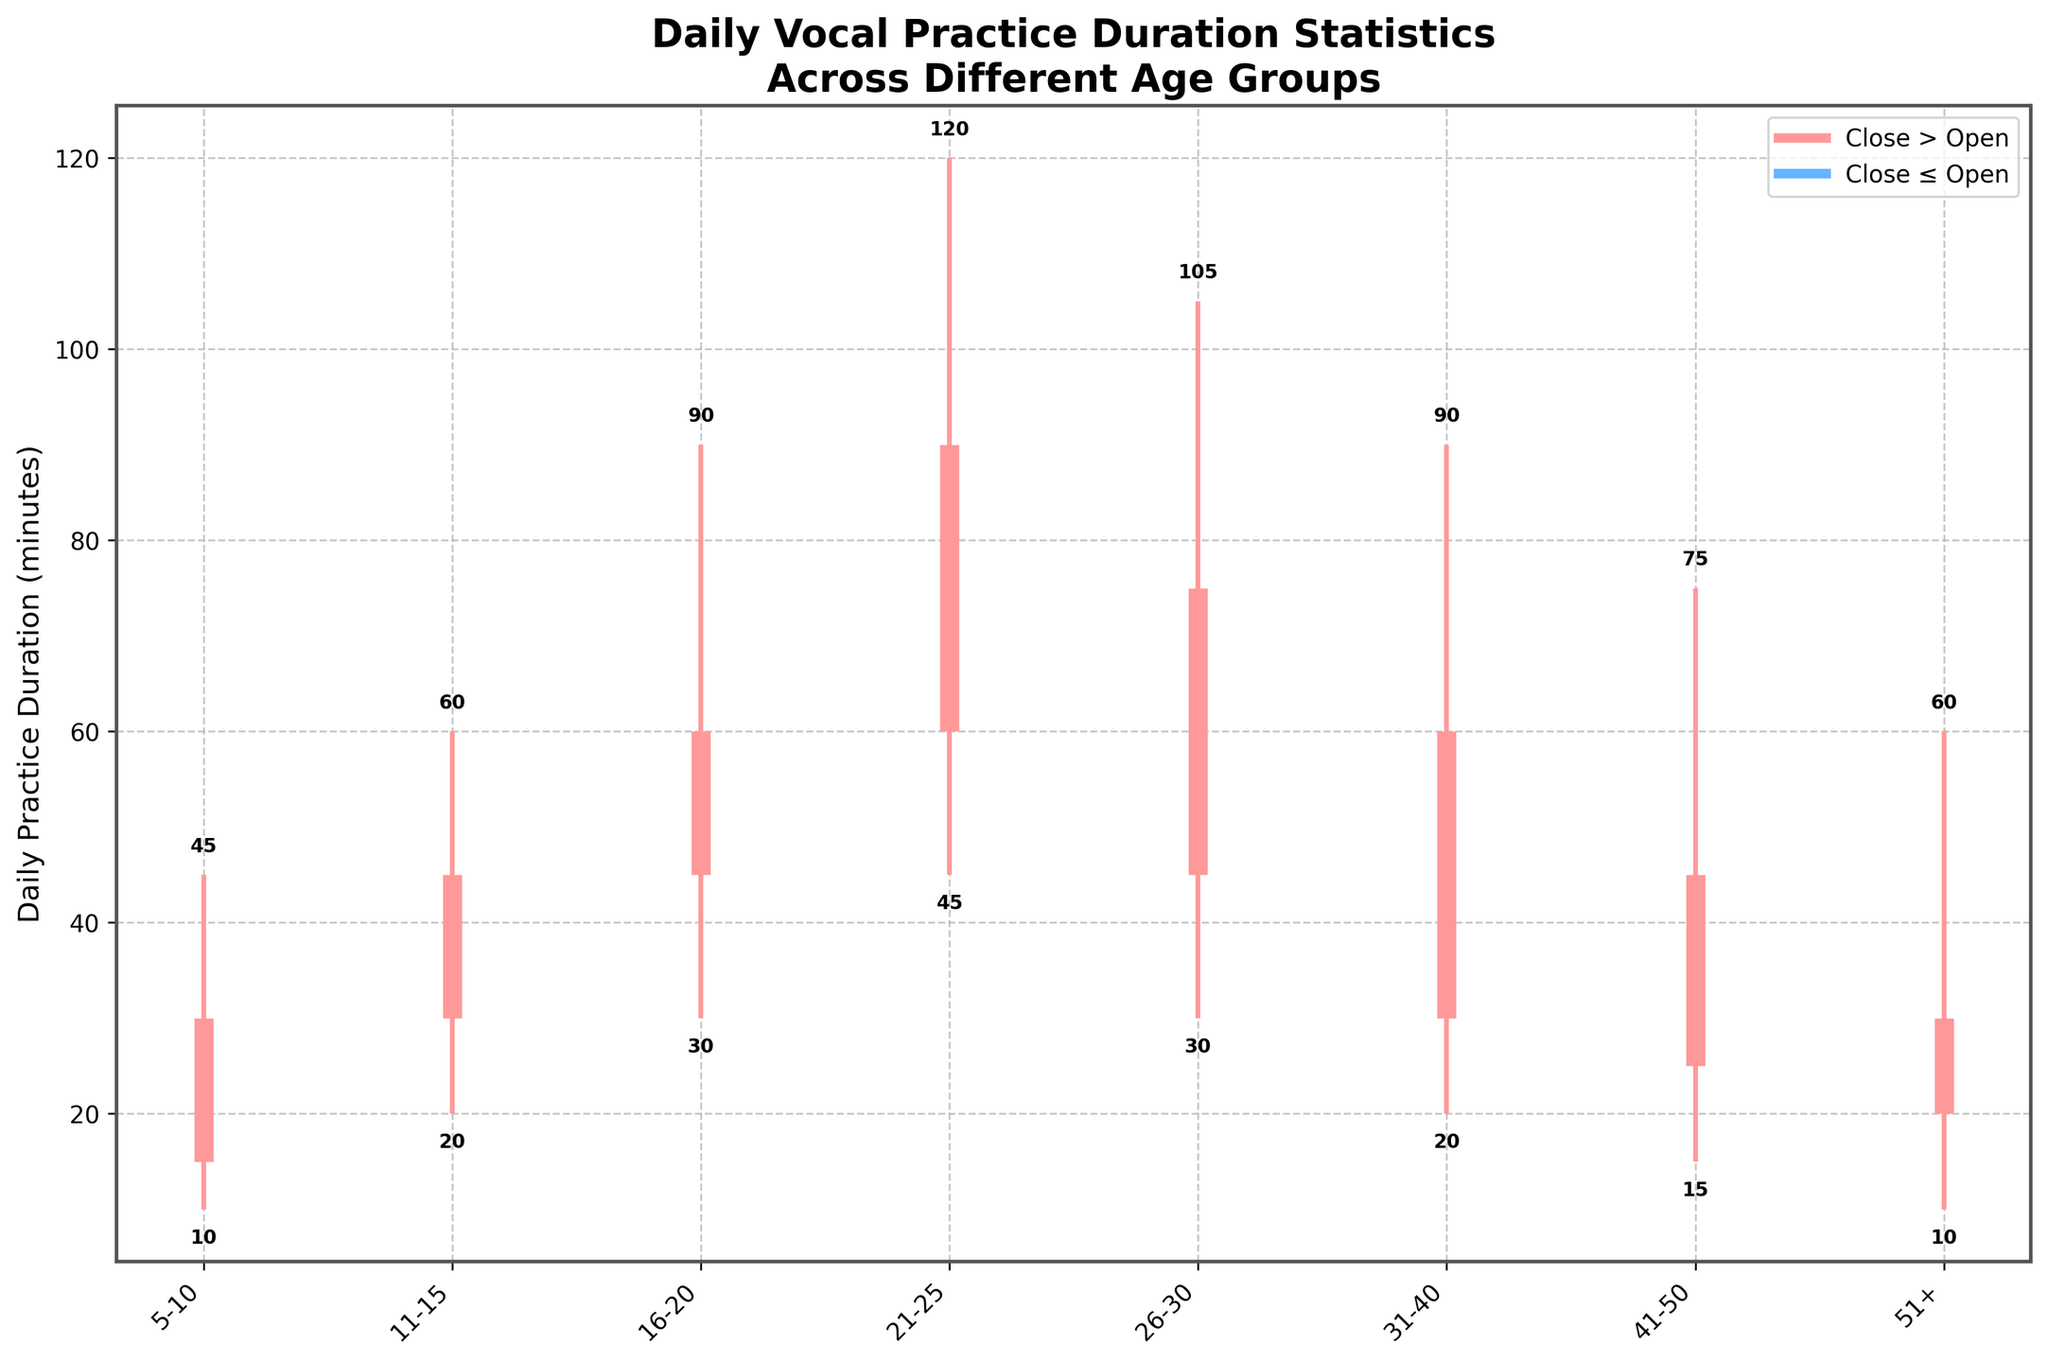What is the high value for the 21-25 age group? The high value for the 21-25 age group can be found by locating the highest point of the line representing that age group.
Answer: 120 Which age group has the smallest low value? The age group with the smallest low value can be identified by observing the lowest point reached by the lines.
Answer: 51+ What is the difference between the open and close values for the 16-20 age group? Subtract the open value from the close value for the 16-20 age group (60 - 45 = 15).
Answer: 15 Which age group had the highest variation in practice durations (difference between high and low values)? The variation is calculated by subtracting the low value from the high value for each age group. The largest difference indicates the highest variation.
Answer: 21-25 How many age groups have a close value greater than their open value? Count the number of age groups where the close value is higher than the open value. This can be visually identified by the thicker horizontal lines being above their starting points (open).
Answer: 6 What is the average of the close values for the age groups between 31-40 and 51+? Add the close values for the age groups 31-40 and 51+ and then divide by the number of age groups to find the average ((60 + 45 + 30) / 3).
Answer: 45 What is the range of the close values in the dataset? The range is calculated by subtracting the smallest close value from the largest close value (90 - 30 = 60).
Answer: 60 Which age group has the smallest difference between their high and low values? Calculate the difference between high and low values for each age group and identify the smallest one.
Answer: 51+ Which age group has the highest open value? Observe the starting points (open values) on the chart to identify the highest one among all age groups.
Answer: 21-25 